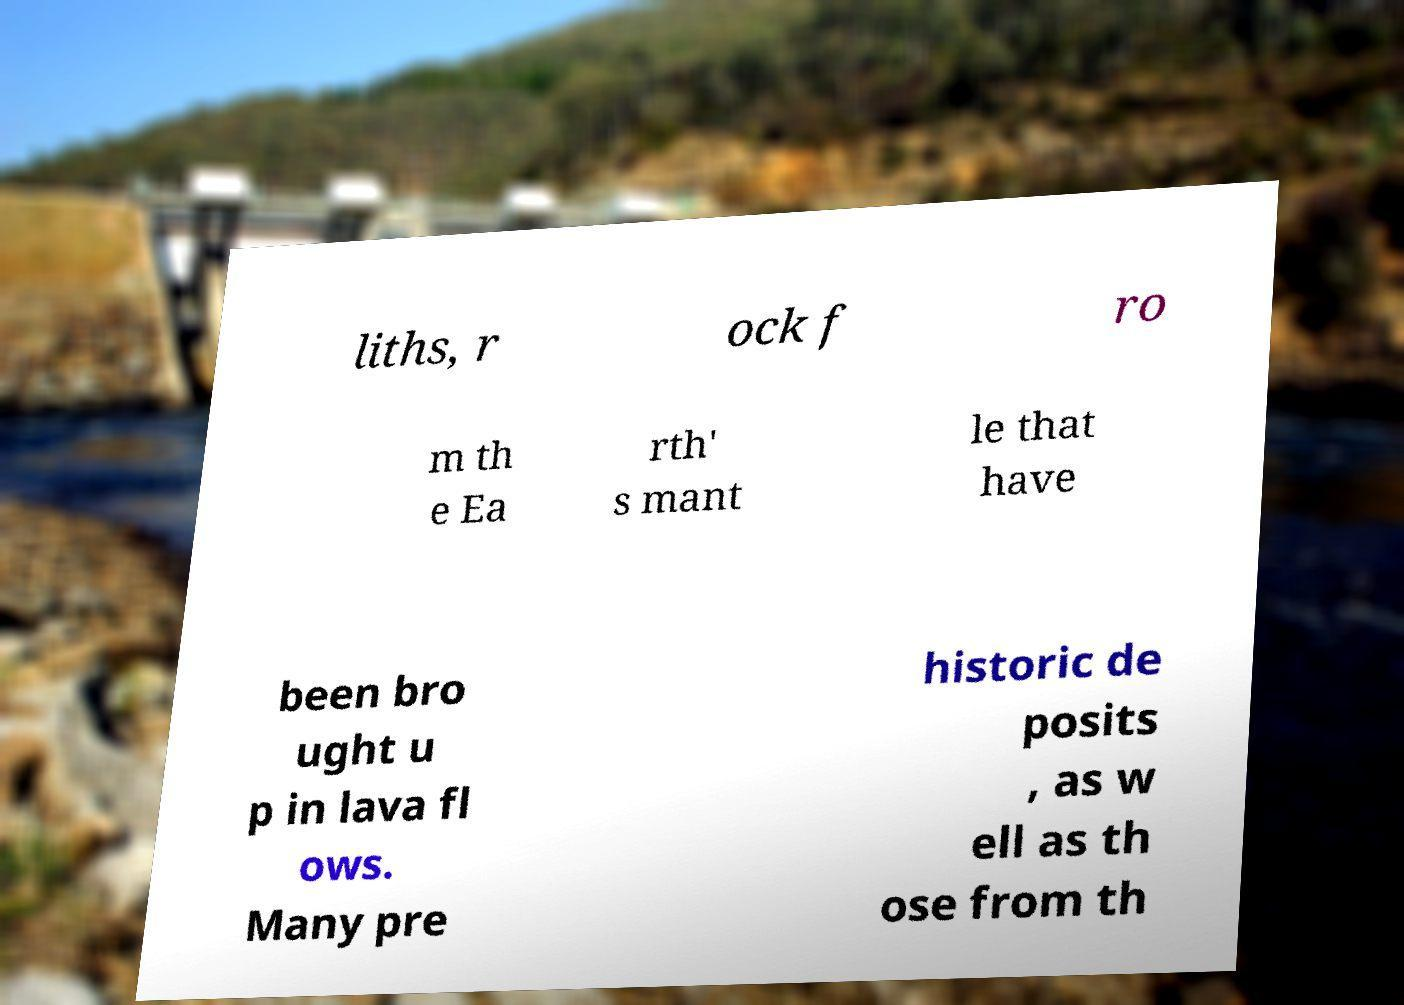For documentation purposes, I need the text within this image transcribed. Could you provide that? liths, r ock f ro m th e Ea rth' s mant le that have been bro ught u p in lava fl ows. Many pre historic de posits , as w ell as th ose from th 